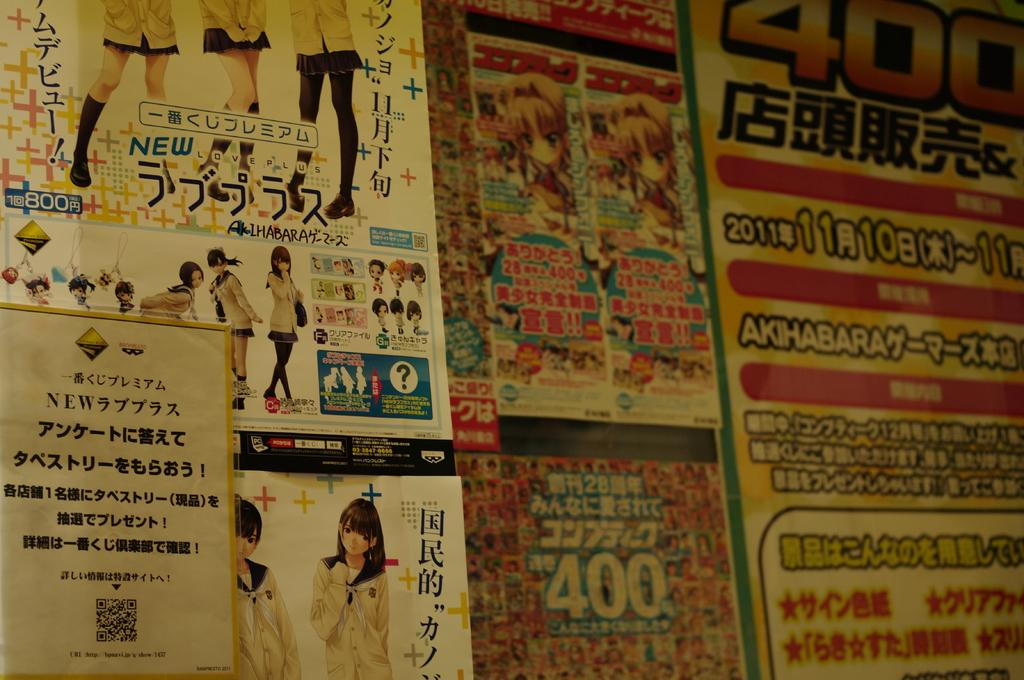Provide a one-sentence caption for the provided image. Many of these products are labeled either 400 or 800. 